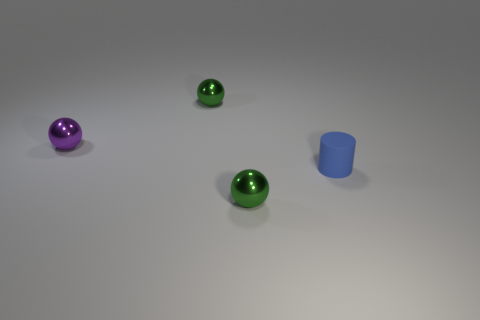Is the shape of the tiny metal thing behind the tiny purple object the same as the metallic thing that is in front of the purple metallic object?
Provide a short and direct response. Yes. What shape is the thing that is in front of the tiny blue rubber cylinder?
Keep it short and to the point. Sphere. Are there the same number of green spheres behind the blue thing and small purple metallic spheres to the left of the tiny purple shiny ball?
Your response must be concise. No. What number of objects are either big yellow things or things on the right side of the small purple metallic sphere?
Your response must be concise. 3. There is a thing that is both in front of the tiny purple ball and left of the tiny blue matte thing; what is its shape?
Keep it short and to the point. Sphere. There is a green sphere that is on the right side of the small green metal thing that is behind the small cylinder; what is its material?
Ensure brevity in your answer.  Metal. Are the ball that is in front of the small purple sphere and the small purple thing made of the same material?
Your answer should be very brief. Yes. What size is the green metal sphere that is in front of the small cylinder?
Your response must be concise. Small. There is a tiny ball that is behind the purple shiny thing; are there any green metallic balls that are on the right side of it?
Give a very brief answer. Yes. Does the sphere that is in front of the small blue object have the same color as the object that is behind the purple metal ball?
Offer a terse response. Yes. 